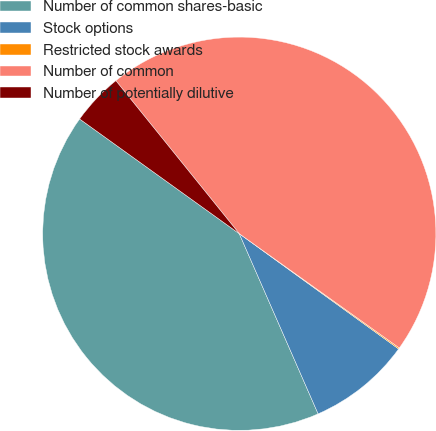<chart> <loc_0><loc_0><loc_500><loc_500><pie_chart><fcel>Number of common shares-basic<fcel>Stock options<fcel>Restricted stock awards<fcel>Number of common<fcel>Number of potentially dilutive<nl><fcel>41.48%<fcel>8.47%<fcel>0.1%<fcel>45.67%<fcel>4.28%<nl></chart> 